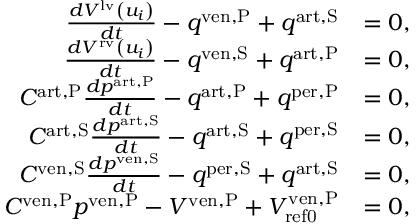<formula> <loc_0><loc_0><loc_500><loc_500>\begin{array} { r l } { \frac { d V ^ { l v } \left ( u _ { i } \right ) } { d t } - q ^ { v e n , P } + q ^ { a r t , S } } & { = 0 , } \\ { \frac { d V ^ { r v } \left ( u _ { i } \right ) } { d t } - q ^ { v e n , S } + q ^ { a r t , P } } & { = 0 , } \\ { C ^ { a r t , P } \frac { d p ^ { a r t , P } } { d t } - q ^ { a r t , P } + q ^ { p e r , P } } & { = 0 , } \\ { C ^ { a r t , S } \frac { d p ^ { a r t , S } } { d t } - q ^ { a r t , S } + q ^ { p e r , S } } & { = 0 , } \\ { C ^ { v e n , S } \frac { d p ^ { v e n , S } } { d t } - q ^ { p e r , S } + q ^ { a r t , S } } & { = 0 , } \\ { C ^ { v e n , P } p ^ { v e n , P } - V ^ { v e n , P } + V _ { r e f 0 } ^ { v e n , P } } & { = 0 , } \end{array}</formula> 